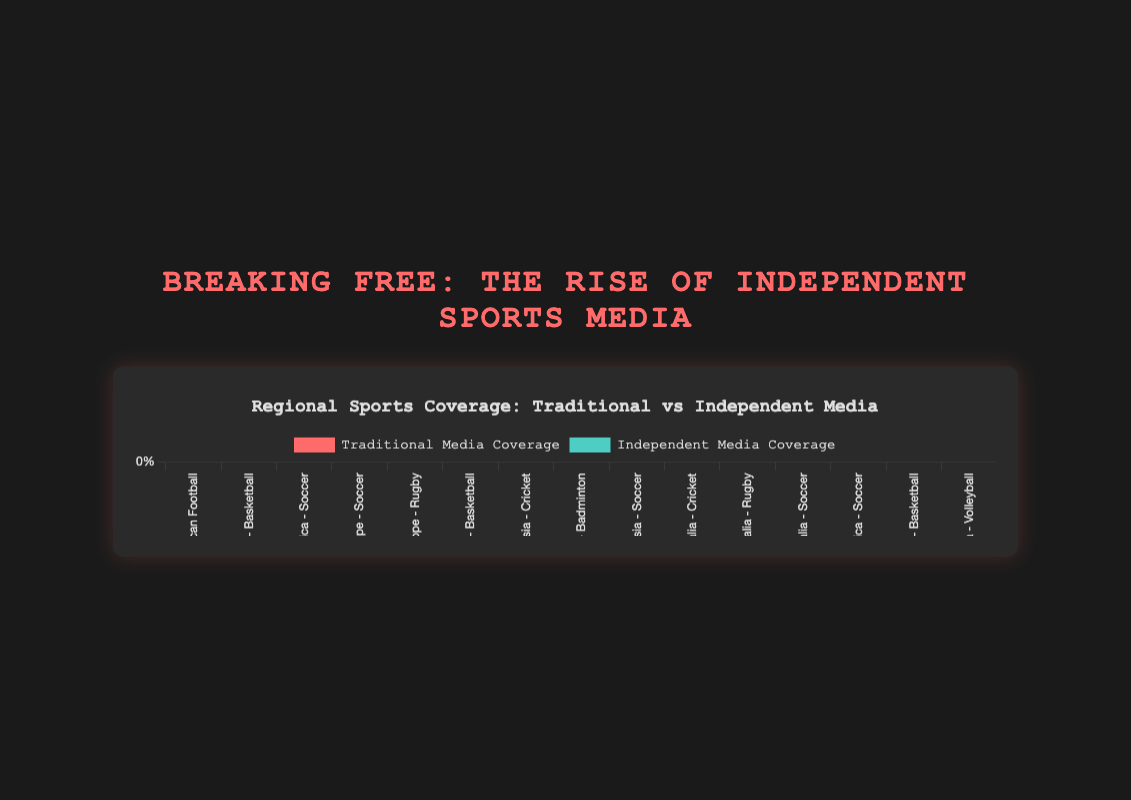What's the sport with the highest independent media coverage in North America? By looking at the bars representing independent media coverage in North America (orange bars) for each sport, we notice that Soccer has the highest value at 70.
Answer: Soccer Which sport in Europe has the least traditional media coverage? To determine the sport with the least traditional media coverage (blue bars) in Europe, compare the values for Soccer (80), Rugby (60), and Basketball (40). Basketball has the lowest value.
Answer: Basketball Compare the total independent media coverage for Soccer between North America and Europe. Which region has more? In North America, Soccer's independent media coverage is 70. In Europe, it is 20. North America has more.
Answer: North America What's the average traditional media coverage for Cricket across Asia and Australia? Add the traditional media coverage values for Cricket in Asia (70) and Australia (60), then divide by 2. The average is (70 + 60) / 2 = 65.
Answer: 65 What is the difference in independent media coverage between Rugby in Australia and Rugby in Europe? The independent media coverage for Rugby in Australia is 35, and in Europe, it is 40. The difference is 40 - 35 = 5.
Answer: 5 Which sport in South America has the highest independent media coverage? In South America, compare the independent media coverage values for Soccer (20), Basketball (60), and Volleyball (55). Basketball has the highest value.
Answer: Basketball Is traditional media coverage always greater than independent media coverage in Europe? For each sport in Europe, compare traditional media coverage to independent media coverage. Soccer (80 vs 20), Rugby (60 vs 40), and Basketball (40 vs 60). For Basketball, independent coverage is greater.
Answer: No Which sport in which region has the most balanced media coverage between traditional and independent media? Examine each region and sport to find the smallest difference between traditional and independent media. Basketball in North America has 50 vs 50, which is perfectly balanced.
Answer: Basketball in North America Calculate the total traditional media coverage for Soccer across all regions. Sum the traditional media coverage values for Soccer: North America (30) + Europe (80) + Asia (50) + Australia (50) + South America (80). The total is 30 + 80 + 50 + 50 + 80 = 290.
Answer: 290 